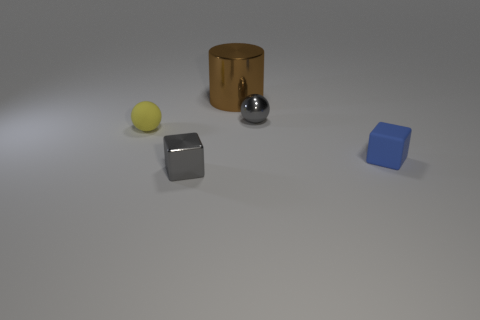Subtract all gray spheres. How many spheres are left? 1 Subtract all cubes. How many objects are left? 3 Subtract all brown things. Subtract all metal cylinders. How many objects are left? 3 Add 5 blue blocks. How many blue blocks are left? 6 Add 1 small gray shiny objects. How many small gray shiny objects exist? 3 Add 1 large cyan blocks. How many objects exist? 6 Subtract 0 green cylinders. How many objects are left? 5 Subtract 1 blocks. How many blocks are left? 1 Subtract all blue cylinders. Subtract all brown balls. How many cylinders are left? 1 Subtract all green cylinders. How many yellow spheres are left? 1 